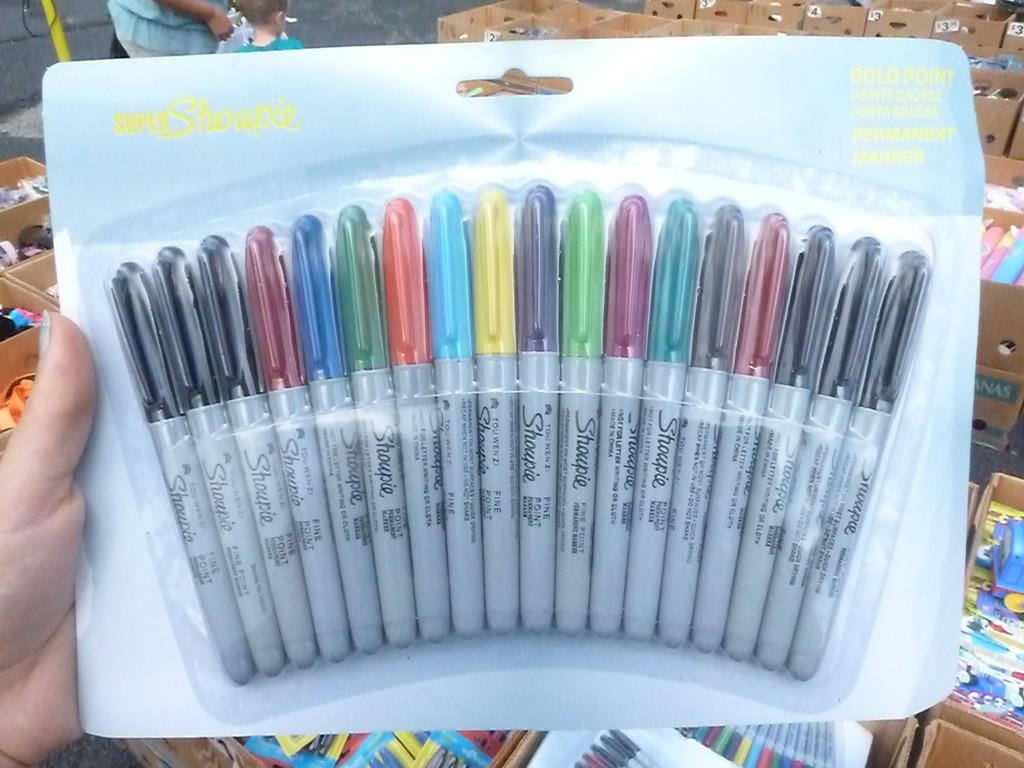What type of writing or drawing tools are present in the image? The image contains sketch pens in different colors. What other stationery items can be seen in the image? There are many stationery items in the image. Can you describe the people in the image? Two persons are standing on the road in the image. What type of rice is being harvested in the background of the image? There is no rice or harvesting activity present in the image. 